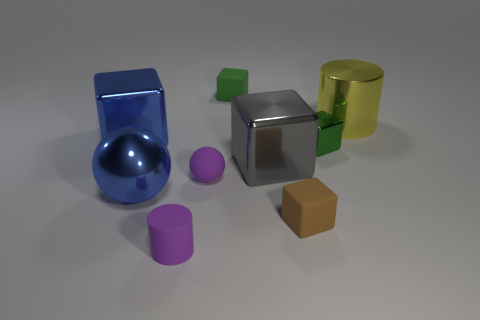Subtract all brown matte cubes. How many cubes are left? 4 Add 1 green metallic cubes. How many objects exist? 10 Subtract all blue blocks. How many blocks are left? 4 Subtract all cubes. How many objects are left? 4 Subtract 1 spheres. How many spheres are left? 1 Subtract all purple balls. Subtract all cyan blocks. How many balls are left? 1 Subtract all red balls. How many purple cubes are left? 0 Subtract all yellow cylinders. Subtract all blue metal things. How many objects are left? 6 Add 4 small green metal things. How many small green metal things are left? 5 Add 5 big cyan matte cubes. How many big cyan matte cubes exist? 5 